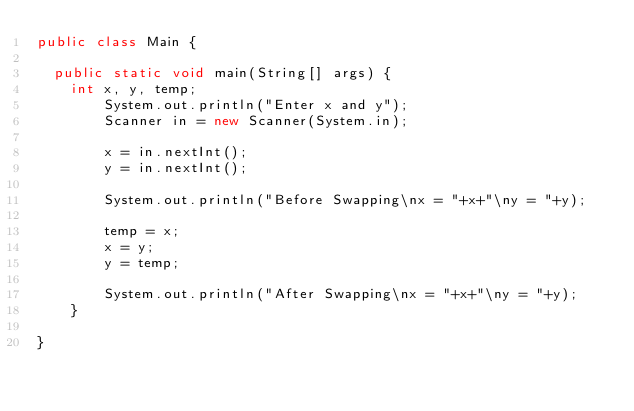<code> <loc_0><loc_0><loc_500><loc_500><_Java_>public class Main {
	
	public static void main(String[] args) {
		int x, y, temp;
	      System.out.println("Enter x and y");
	      Scanner in = new Scanner(System.in);
	 
	      x = in.nextInt();
	      y = in.nextInt();
	 
	      System.out.println("Before Swapping\nx = "+x+"\ny = "+y);
	 
	      temp = x;
	      x = y;
	      y = temp;
	 
	      System.out.println("After Swapping\nx = "+x+"\ny = "+y);
    }

}
</code> 